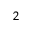Convert formula to latex. <formula><loc_0><loc_0><loc_500><loc_500>^ { 2 }</formula> 